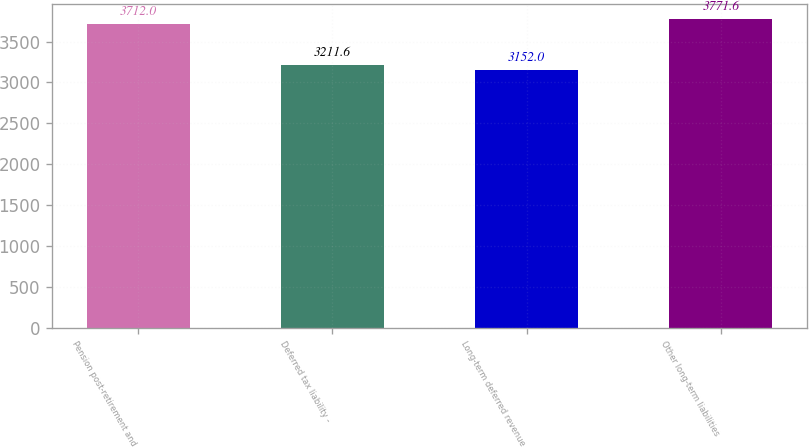Convert chart. <chart><loc_0><loc_0><loc_500><loc_500><bar_chart><fcel>Pension post-retirement and<fcel>Deferred tax liability -<fcel>Long-term deferred revenue<fcel>Other long-term liabilities<nl><fcel>3712<fcel>3211.6<fcel>3152<fcel>3771.6<nl></chart> 